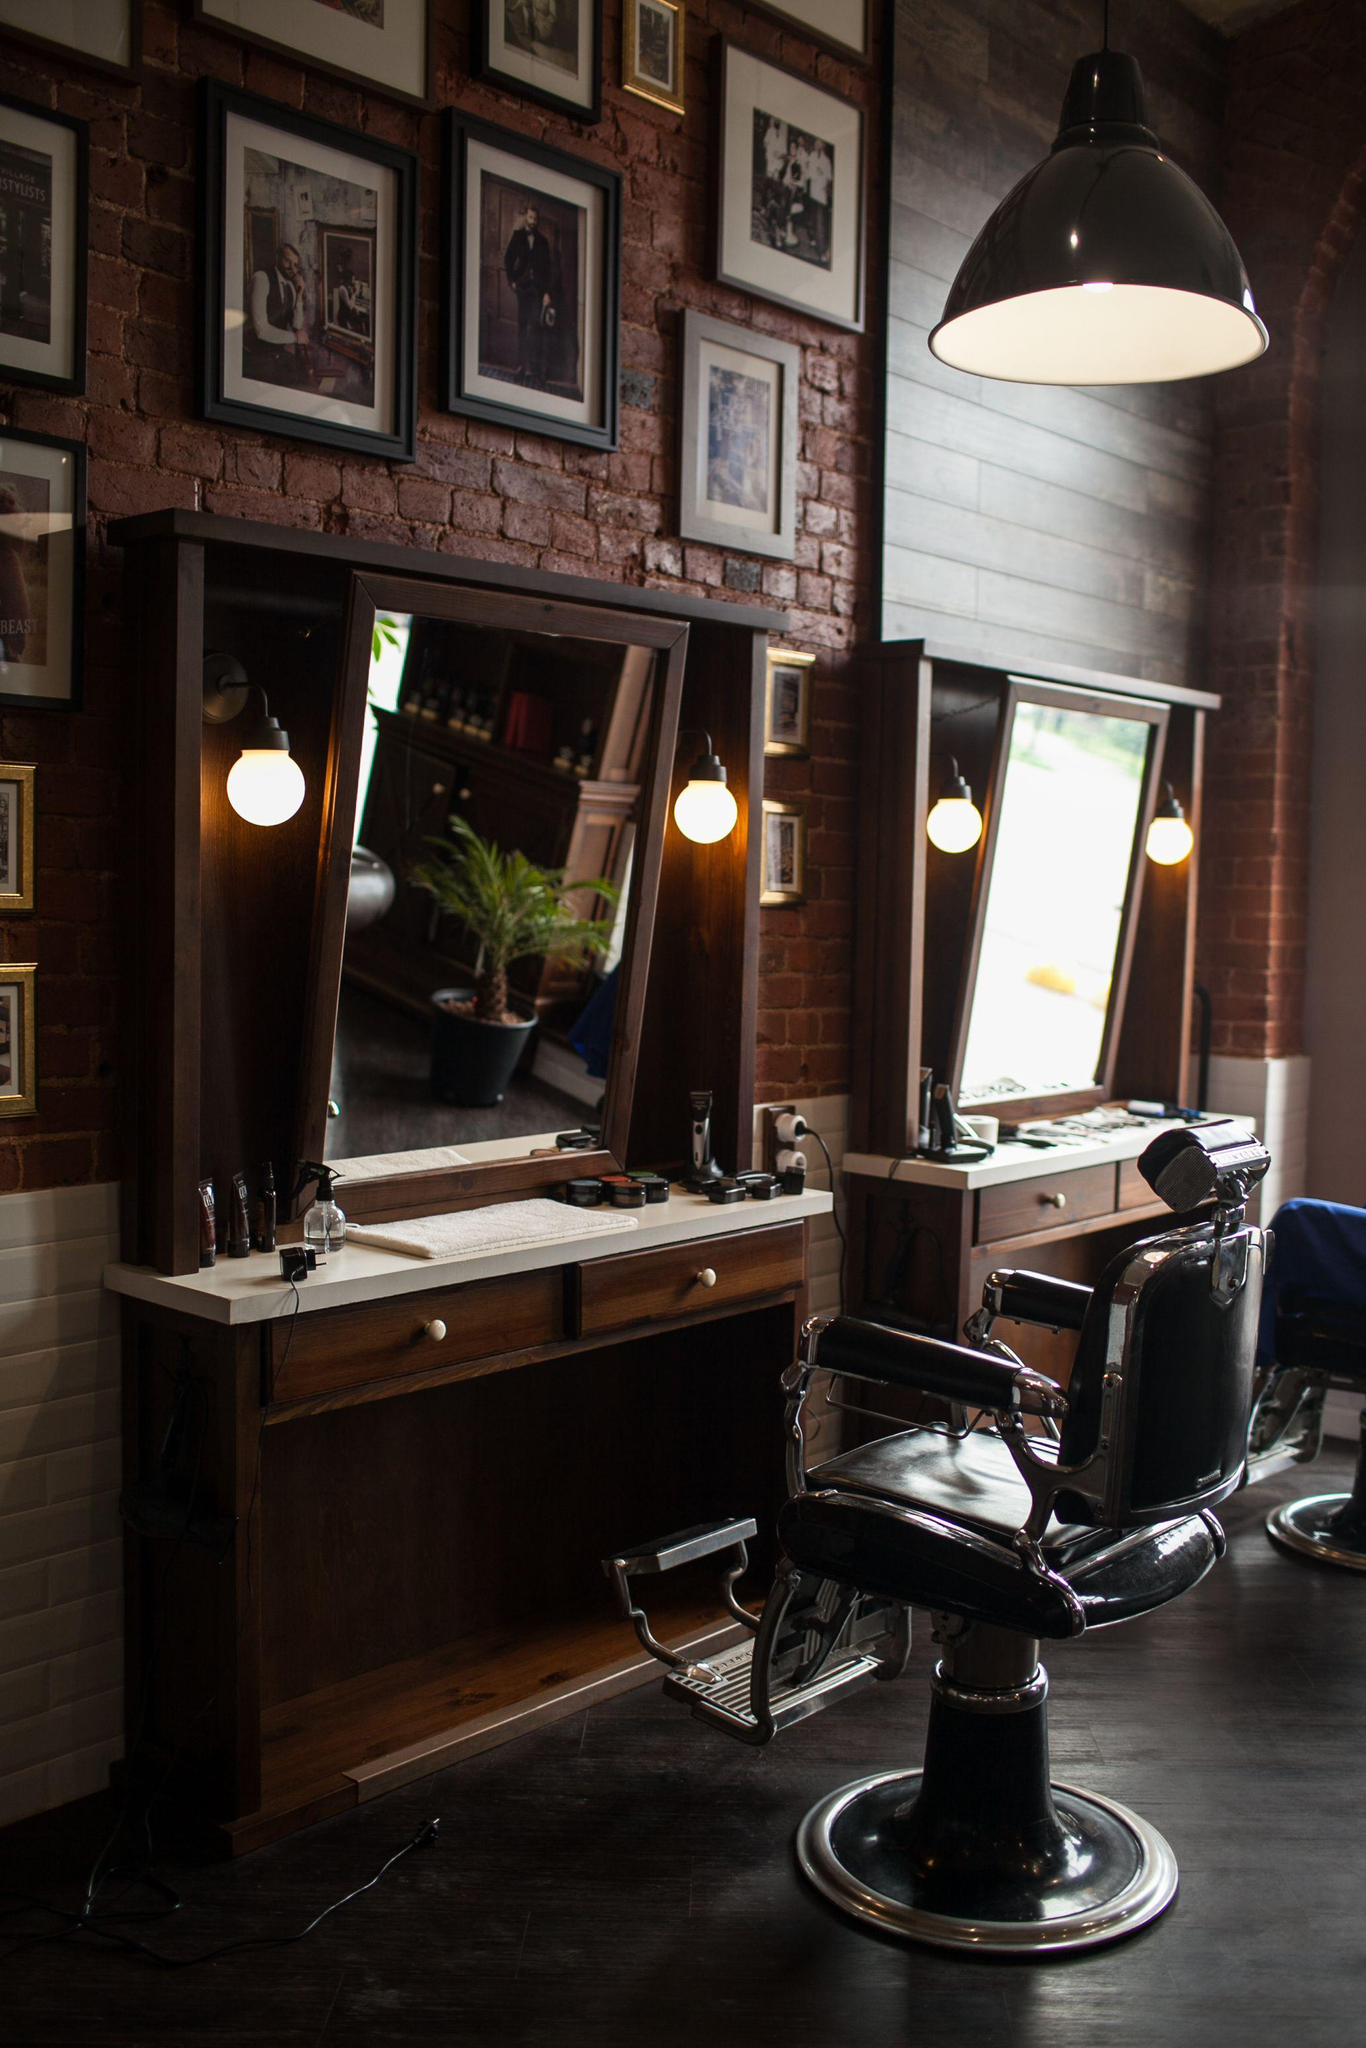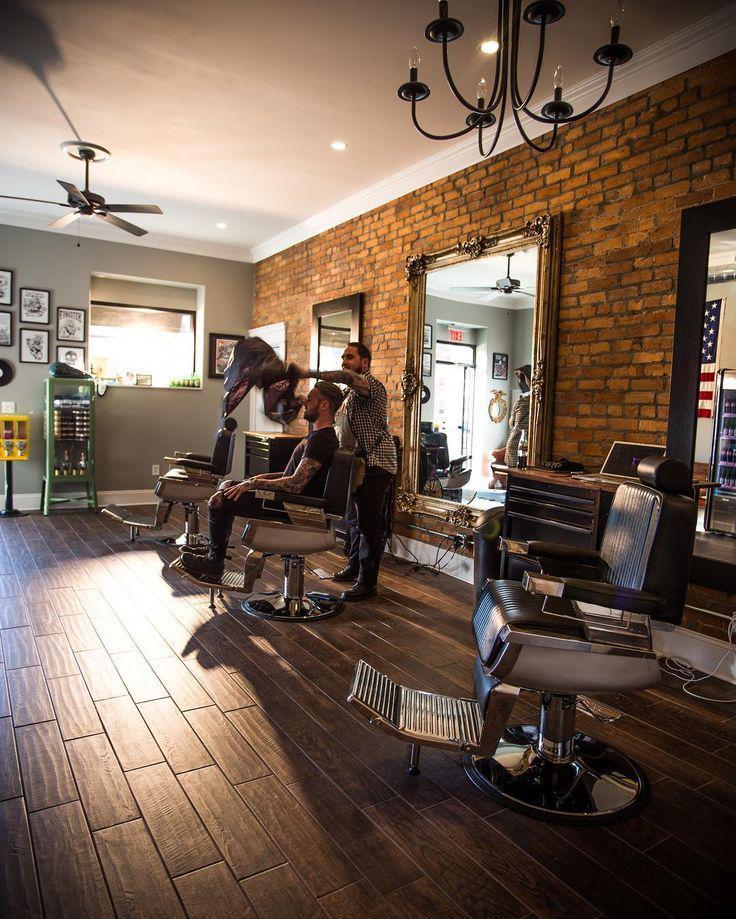The first image is the image on the left, the second image is the image on the right. Examine the images to the left and right. Is the description "There is at least five people's reflections in the mirror." accurate? Answer yes or no. No. 